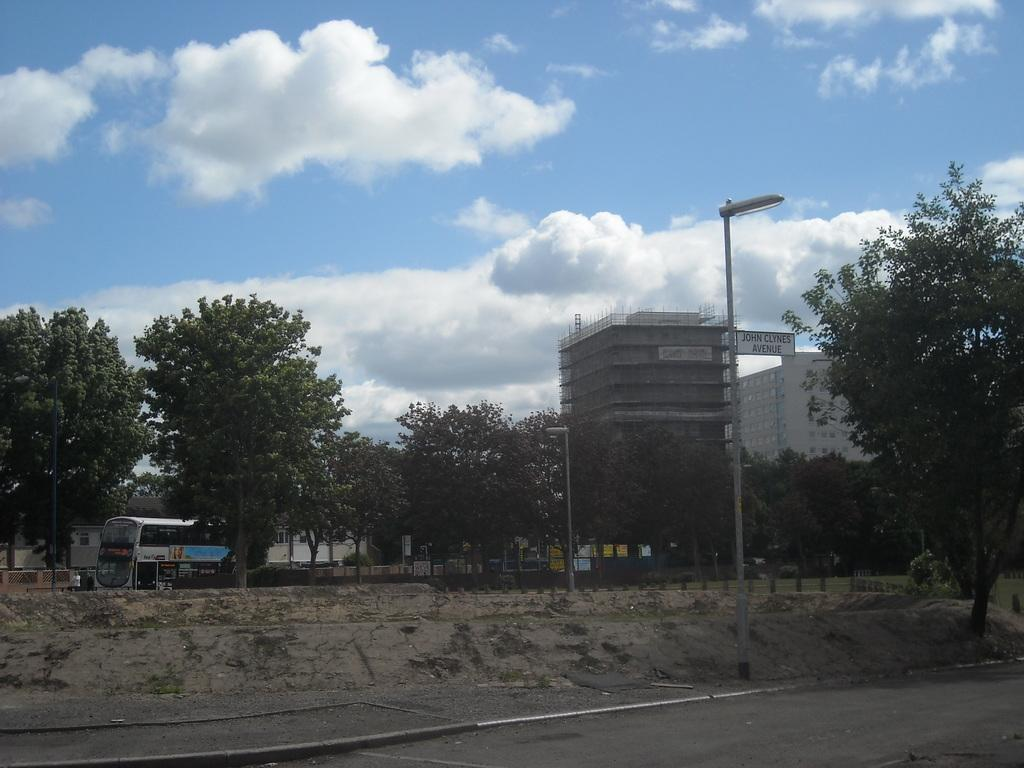What structures can be seen in the image? There are poles and trees in the image. What else can be seen in the image besides poles and trees? There are vehicles in the image. What can be seen in the background of the image? In the background, there are buildings, hoardings, and clouds. What type of fruit is hanging from the poles in the image? There is no fruit hanging from the poles in the image. What grade is the school building in the background? There is no school building present in the image, so it is not possible to determine its grade. 